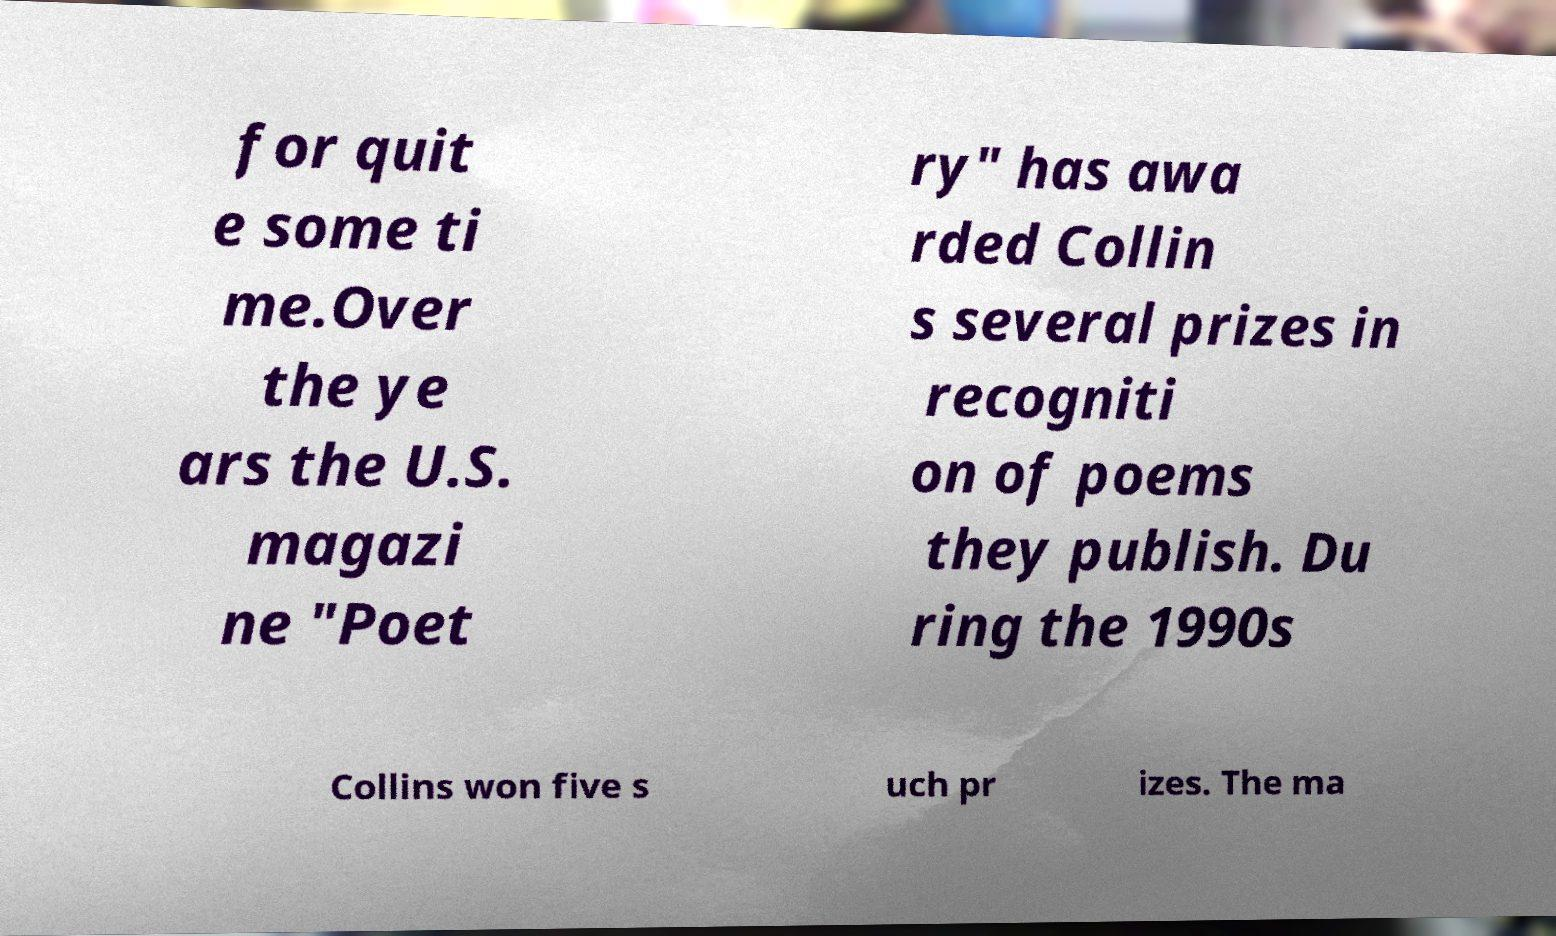What messages or text are displayed in this image? I need them in a readable, typed format. for quit e some ti me.Over the ye ars the U.S. magazi ne "Poet ry" has awa rded Collin s several prizes in recogniti on of poems they publish. Du ring the 1990s Collins won five s uch pr izes. The ma 